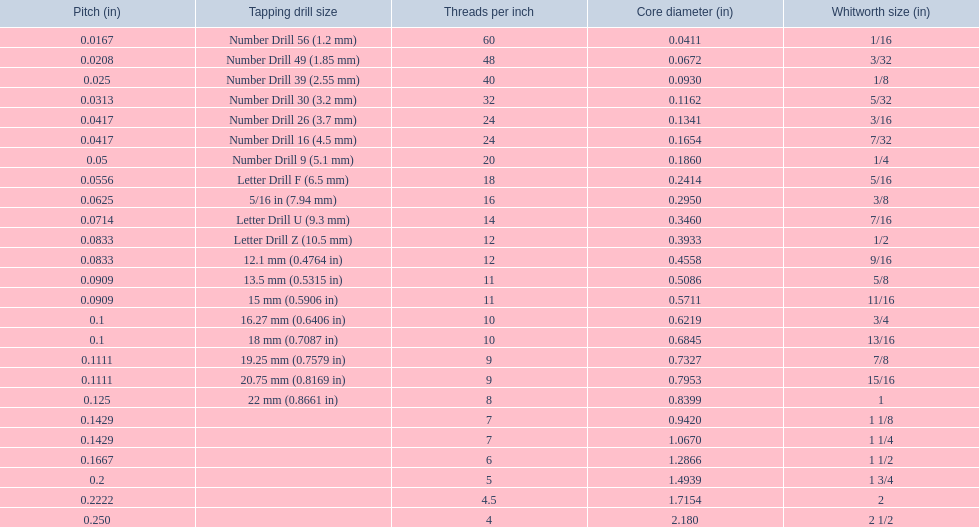What are the sizes of threads per inch? 60, 48, 40, 32, 24, 24, 20, 18, 16, 14, 12, 12, 11, 11, 10, 10, 9, 9, 8, 7, 7, 6, 5, 4.5, 4. Which whitworth size has only 5 threads per inch? 1 3/4. 